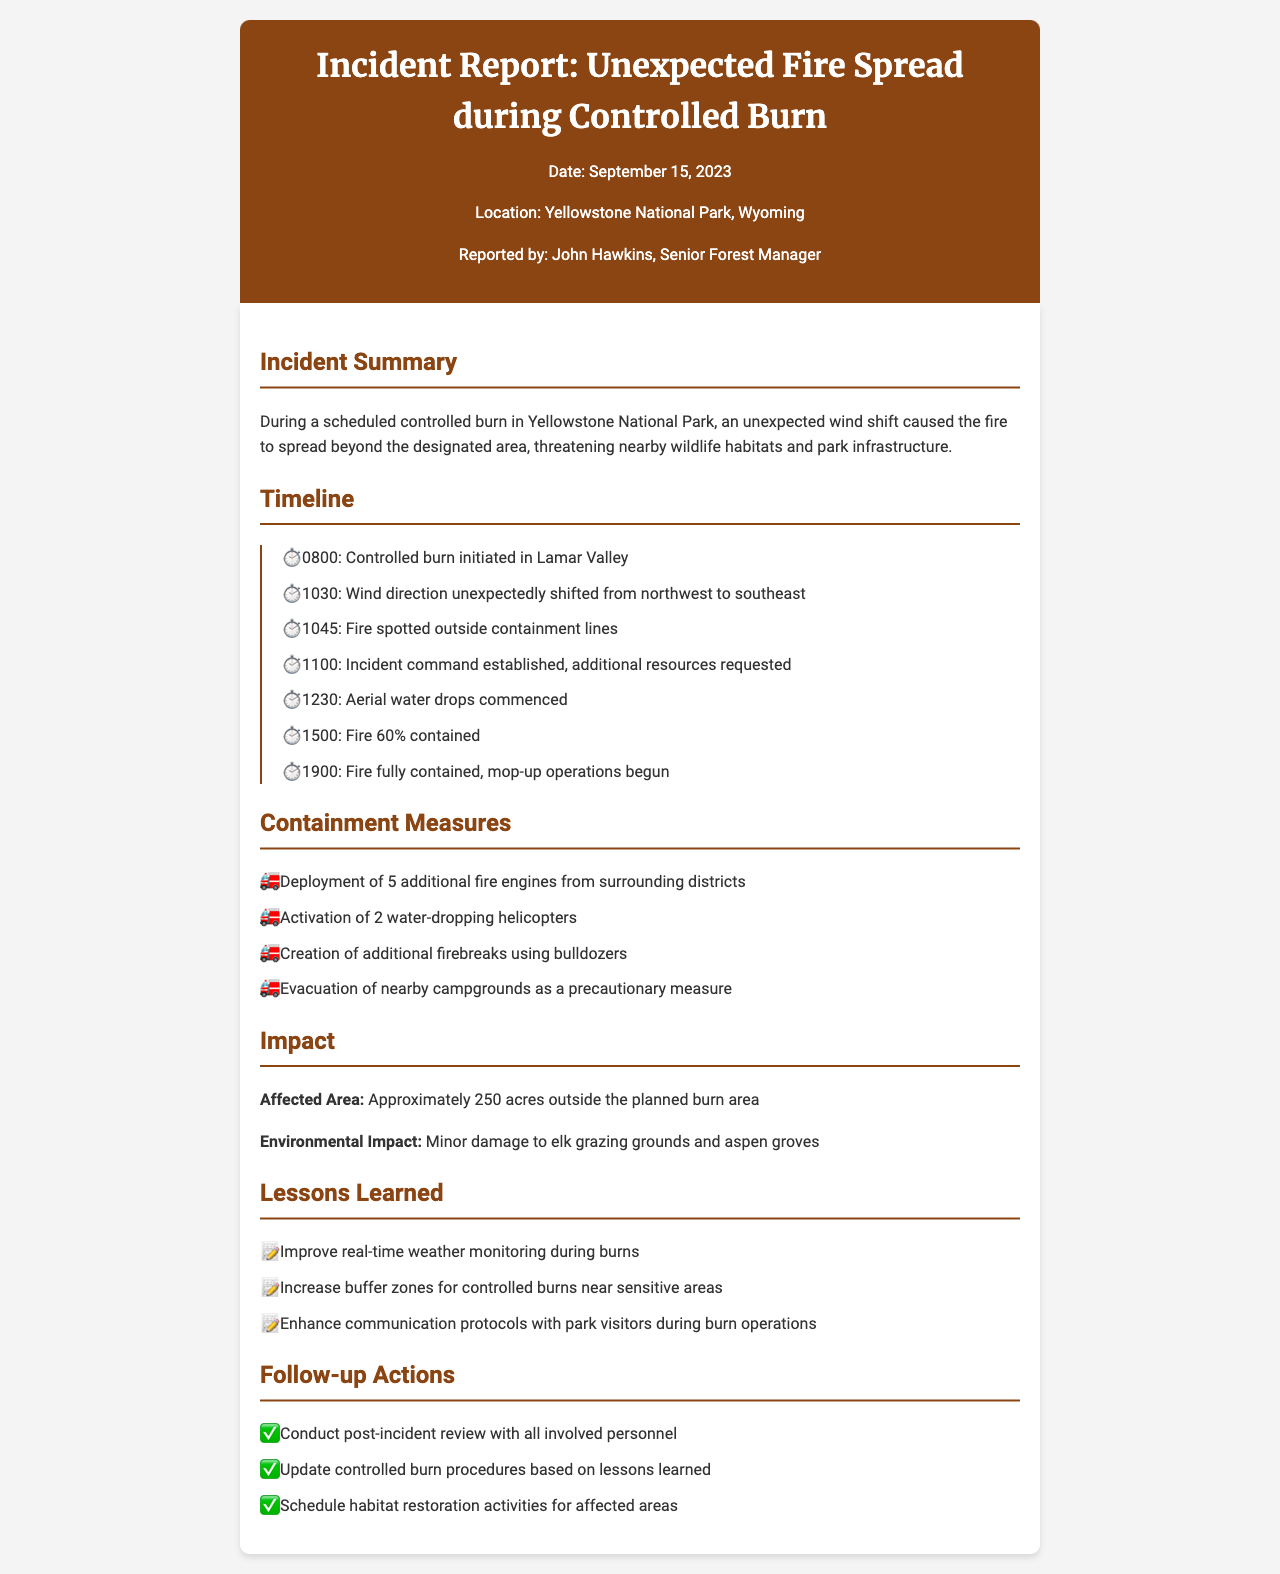What date did the incident occur? The date of the incident is mentioned in the document header.
Answer: September 15, 2023 What was the location of the incident? The location is stated in the document header.
Answer: Yellowstone National Park, Wyoming Who reported the incident? The name of the reporter is given in the document header.
Answer: John Hawkins What caused the fire to spread unexpectedly? The reason for the unexpected fire spread is described in the incident summary.
Answer: Wind shift What time was the fire fully contained? The containment status is noted in the timeline section of the document.
Answer: 1900 How many acres were affected by the fire? The affected area is provided in the impact section.
Answer: Approximately 250 acres What measures were taken for aerial support? The containment measures section lists specific resources deployed for fire control.
Answer: 2 water-dropping helicopters What lesson is focused on improving monitoring? The lessons learned section mentions specific areas for improvement related to the incident.
Answer: Real-time weather monitoring What is the first follow-up action mentioned? The follow-up actions section outlines specific actions to be taken post-incident.
Answer: Conduct post-incident review 